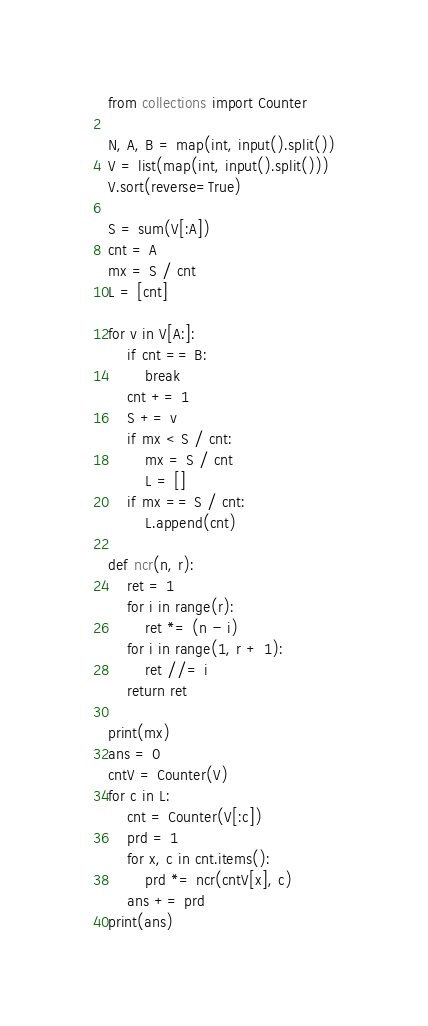<code> <loc_0><loc_0><loc_500><loc_500><_Python_>from collections import Counter

N, A, B = map(int, input().split())
V = list(map(int, input().split()))
V.sort(reverse=True)

S = sum(V[:A])
cnt = A
mx = S / cnt
L = [cnt]

for v in V[A:]:
    if cnt == B:
        break
    cnt += 1
    S += v
    if mx < S / cnt:
        mx = S / cnt
        L = []
    if mx == S / cnt:
        L.append(cnt)

def ncr(n, r):
    ret = 1
    for i in range(r):
        ret *= (n - i)
    for i in range(1, r + 1):
        ret //= i
    return ret

print(mx)
ans = 0
cntV = Counter(V)
for c in L:
    cnt = Counter(V[:c])
    prd = 1
    for x, c in cnt.items():
        prd *= ncr(cntV[x], c)
    ans += prd
print(ans)
</code> 